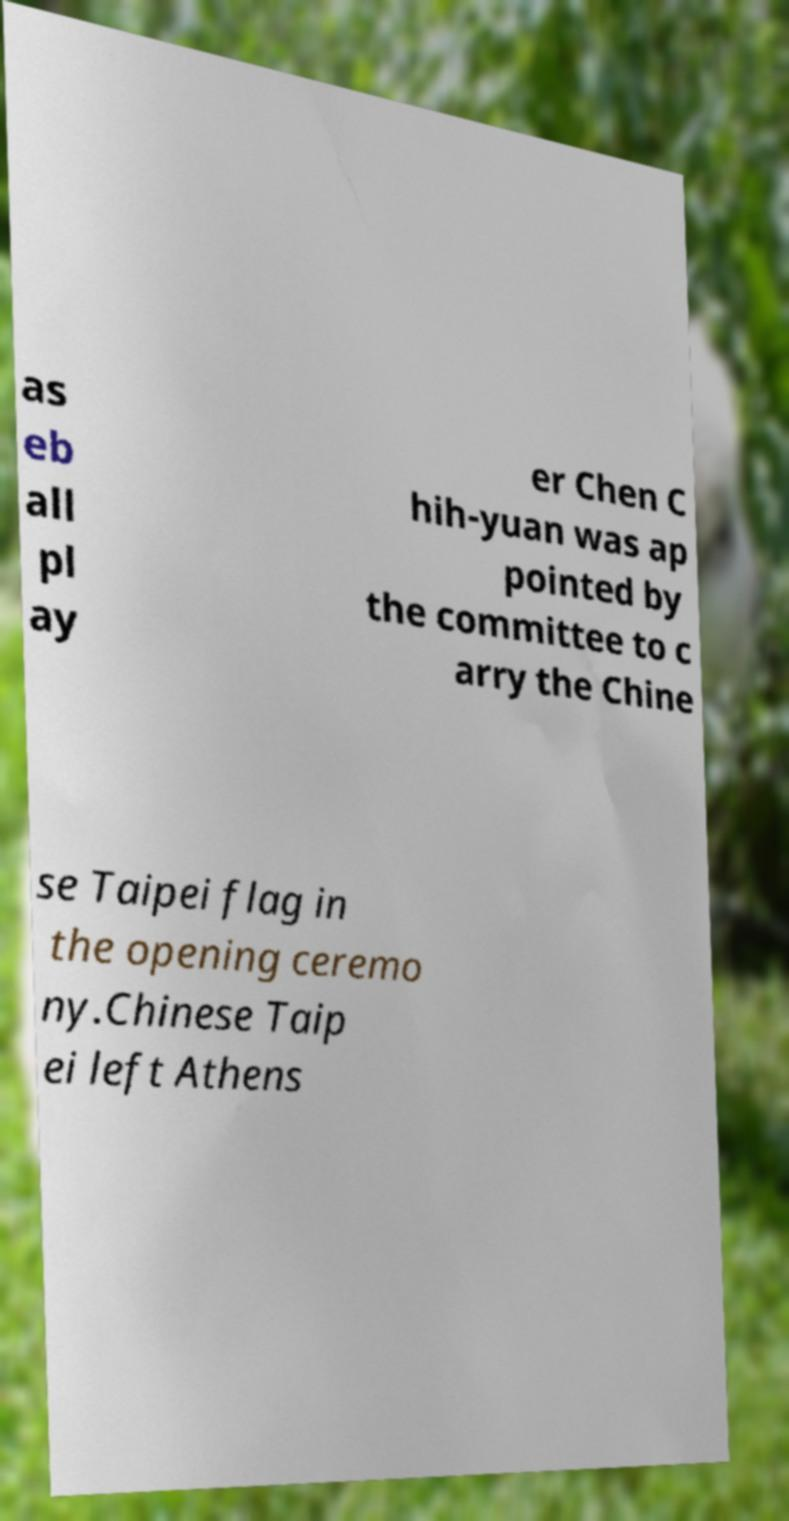Could you assist in decoding the text presented in this image and type it out clearly? as eb all pl ay er Chen C hih-yuan was ap pointed by the committee to c arry the Chine se Taipei flag in the opening ceremo ny.Chinese Taip ei left Athens 